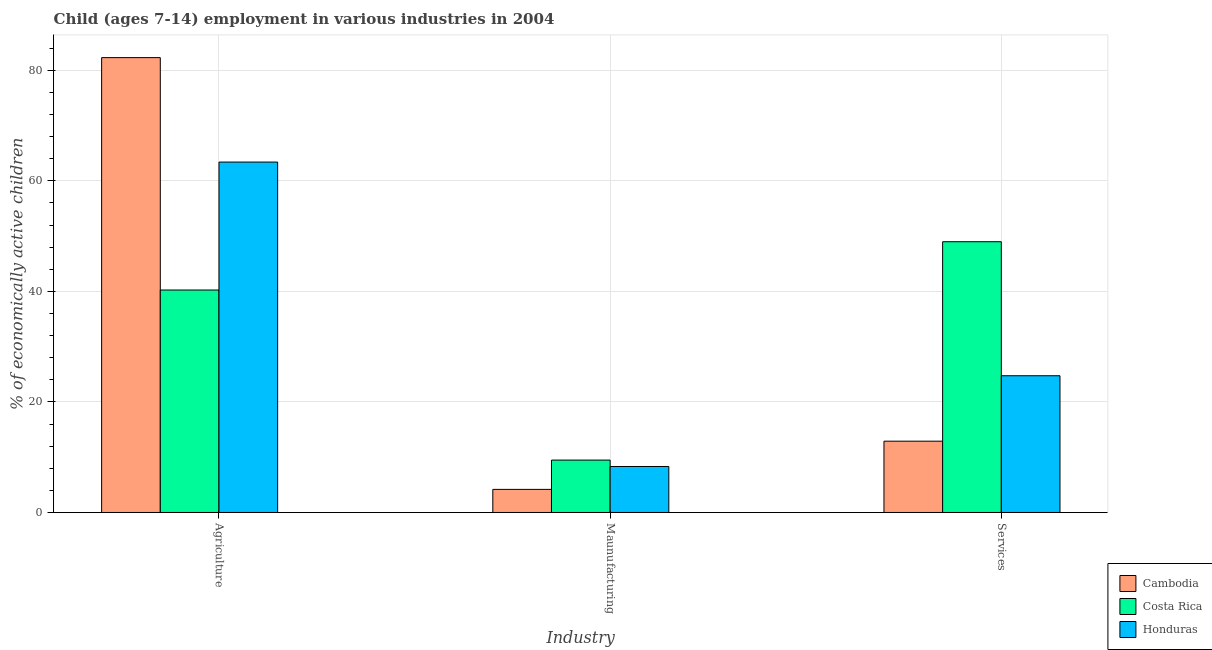How many different coloured bars are there?
Your answer should be very brief. 3. How many groups of bars are there?
Offer a terse response. 3. How many bars are there on the 2nd tick from the left?
Offer a very short reply. 3. How many bars are there on the 1st tick from the right?
Offer a terse response. 3. What is the label of the 1st group of bars from the left?
Offer a very short reply. Agriculture. What is the percentage of economically active children in manufacturing in Cambodia?
Offer a terse response. 4.18. Across all countries, what is the maximum percentage of economically active children in manufacturing?
Offer a very short reply. 9.48. In which country was the percentage of economically active children in manufacturing maximum?
Keep it short and to the point. Costa Rica. In which country was the percentage of economically active children in services minimum?
Offer a terse response. Cambodia. What is the total percentage of economically active children in services in the graph?
Offer a terse response. 86.63. What is the difference between the percentage of economically active children in manufacturing in Honduras and that in Cambodia?
Your answer should be very brief. 4.14. What is the difference between the percentage of economically active children in manufacturing in Honduras and the percentage of economically active children in services in Cambodia?
Give a very brief answer. -4.58. What is the average percentage of economically active children in agriculture per country?
Your answer should be very brief. 61.98. What is the difference between the percentage of economically active children in manufacturing and percentage of economically active children in services in Honduras?
Your answer should be compact. -16.42. What is the ratio of the percentage of economically active children in manufacturing in Costa Rica to that in Cambodia?
Your answer should be very brief. 2.27. Is the percentage of economically active children in manufacturing in Honduras less than that in Cambodia?
Keep it short and to the point. No. Is the difference between the percentage of economically active children in agriculture in Cambodia and Honduras greater than the difference between the percentage of economically active children in services in Cambodia and Honduras?
Ensure brevity in your answer.  Yes. What is the difference between the highest and the second highest percentage of economically active children in agriculture?
Your answer should be compact. 18.9. What is the difference between the highest and the lowest percentage of economically active children in agriculture?
Provide a short and direct response. 42.05. In how many countries, is the percentage of economically active children in agriculture greater than the average percentage of economically active children in agriculture taken over all countries?
Provide a short and direct response. 2. Is the sum of the percentage of economically active children in services in Honduras and Costa Rica greater than the maximum percentage of economically active children in agriculture across all countries?
Your answer should be compact. No. What does the 1st bar from the left in Maunufacturing represents?
Make the answer very short. Cambodia. What does the 1st bar from the right in Services represents?
Provide a succinct answer. Honduras. Is it the case that in every country, the sum of the percentage of economically active children in agriculture and percentage of economically active children in manufacturing is greater than the percentage of economically active children in services?
Your response must be concise. Yes. How many bars are there?
Offer a very short reply. 9. How many countries are there in the graph?
Make the answer very short. 3. Are the values on the major ticks of Y-axis written in scientific E-notation?
Your response must be concise. No. Does the graph contain any zero values?
Your response must be concise. No. Does the graph contain grids?
Make the answer very short. Yes. How many legend labels are there?
Your response must be concise. 3. What is the title of the graph?
Your answer should be very brief. Child (ages 7-14) employment in various industries in 2004. Does "Low & middle income" appear as one of the legend labels in the graph?
Offer a terse response. No. What is the label or title of the X-axis?
Make the answer very short. Industry. What is the label or title of the Y-axis?
Keep it short and to the point. % of economically active children. What is the % of economically active children in Cambodia in Agriculture?
Give a very brief answer. 82.3. What is the % of economically active children in Costa Rica in Agriculture?
Ensure brevity in your answer.  40.25. What is the % of economically active children in Honduras in Agriculture?
Offer a terse response. 63.4. What is the % of economically active children of Cambodia in Maunufacturing?
Offer a very short reply. 4.18. What is the % of economically active children in Costa Rica in Maunufacturing?
Your answer should be compact. 9.48. What is the % of economically active children of Honduras in Maunufacturing?
Provide a succinct answer. 8.32. What is the % of economically active children in Costa Rica in Services?
Provide a short and direct response. 48.99. What is the % of economically active children in Honduras in Services?
Provide a succinct answer. 24.74. Across all Industry, what is the maximum % of economically active children in Cambodia?
Provide a succinct answer. 82.3. Across all Industry, what is the maximum % of economically active children of Costa Rica?
Make the answer very short. 48.99. Across all Industry, what is the maximum % of economically active children of Honduras?
Keep it short and to the point. 63.4. Across all Industry, what is the minimum % of economically active children of Cambodia?
Give a very brief answer. 4.18. Across all Industry, what is the minimum % of economically active children of Costa Rica?
Ensure brevity in your answer.  9.48. Across all Industry, what is the minimum % of economically active children of Honduras?
Offer a terse response. 8.32. What is the total % of economically active children of Cambodia in the graph?
Offer a terse response. 99.38. What is the total % of economically active children in Costa Rica in the graph?
Your answer should be very brief. 98.72. What is the total % of economically active children in Honduras in the graph?
Provide a short and direct response. 96.46. What is the difference between the % of economically active children in Cambodia in Agriculture and that in Maunufacturing?
Make the answer very short. 78.12. What is the difference between the % of economically active children in Costa Rica in Agriculture and that in Maunufacturing?
Your answer should be compact. 30.77. What is the difference between the % of economically active children of Honduras in Agriculture and that in Maunufacturing?
Make the answer very short. 55.08. What is the difference between the % of economically active children of Cambodia in Agriculture and that in Services?
Provide a short and direct response. 69.4. What is the difference between the % of economically active children of Costa Rica in Agriculture and that in Services?
Your response must be concise. -8.74. What is the difference between the % of economically active children of Honduras in Agriculture and that in Services?
Keep it short and to the point. 38.66. What is the difference between the % of economically active children in Cambodia in Maunufacturing and that in Services?
Provide a succinct answer. -8.72. What is the difference between the % of economically active children of Costa Rica in Maunufacturing and that in Services?
Provide a short and direct response. -39.51. What is the difference between the % of economically active children in Honduras in Maunufacturing and that in Services?
Give a very brief answer. -16.42. What is the difference between the % of economically active children of Cambodia in Agriculture and the % of economically active children of Costa Rica in Maunufacturing?
Your answer should be very brief. 72.82. What is the difference between the % of economically active children of Cambodia in Agriculture and the % of economically active children of Honduras in Maunufacturing?
Offer a very short reply. 73.98. What is the difference between the % of economically active children of Costa Rica in Agriculture and the % of economically active children of Honduras in Maunufacturing?
Ensure brevity in your answer.  31.93. What is the difference between the % of economically active children in Cambodia in Agriculture and the % of economically active children in Costa Rica in Services?
Provide a succinct answer. 33.31. What is the difference between the % of economically active children of Cambodia in Agriculture and the % of economically active children of Honduras in Services?
Give a very brief answer. 57.56. What is the difference between the % of economically active children in Costa Rica in Agriculture and the % of economically active children in Honduras in Services?
Provide a short and direct response. 15.51. What is the difference between the % of economically active children of Cambodia in Maunufacturing and the % of economically active children of Costa Rica in Services?
Keep it short and to the point. -44.81. What is the difference between the % of economically active children of Cambodia in Maunufacturing and the % of economically active children of Honduras in Services?
Provide a short and direct response. -20.56. What is the difference between the % of economically active children in Costa Rica in Maunufacturing and the % of economically active children in Honduras in Services?
Make the answer very short. -15.26. What is the average % of economically active children of Cambodia per Industry?
Keep it short and to the point. 33.13. What is the average % of economically active children of Costa Rica per Industry?
Make the answer very short. 32.91. What is the average % of economically active children of Honduras per Industry?
Make the answer very short. 32.15. What is the difference between the % of economically active children in Cambodia and % of economically active children in Costa Rica in Agriculture?
Your response must be concise. 42.05. What is the difference between the % of economically active children in Cambodia and % of economically active children in Honduras in Agriculture?
Provide a succinct answer. 18.9. What is the difference between the % of economically active children of Costa Rica and % of economically active children of Honduras in Agriculture?
Your response must be concise. -23.15. What is the difference between the % of economically active children of Cambodia and % of economically active children of Honduras in Maunufacturing?
Ensure brevity in your answer.  -4.14. What is the difference between the % of economically active children of Costa Rica and % of economically active children of Honduras in Maunufacturing?
Give a very brief answer. 1.16. What is the difference between the % of economically active children in Cambodia and % of economically active children in Costa Rica in Services?
Your response must be concise. -36.09. What is the difference between the % of economically active children in Cambodia and % of economically active children in Honduras in Services?
Keep it short and to the point. -11.84. What is the difference between the % of economically active children of Costa Rica and % of economically active children of Honduras in Services?
Ensure brevity in your answer.  24.25. What is the ratio of the % of economically active children in Cambodia in Agriculture to that in Maunufacturing?
Offer a very short reply. 19.69. What is the ratio of the % of economically active children of Costa Rica in Agriculture to that in Maunufacturing?
Provide a succinct answer. 4.25. What is the ratio of the % of economically active children of Honduras in Agriculture to that in Maunufacturing?
Provide a short and direct response. 7.62. What is the ratio of the % of economically active children in Cambodia in Agriculture to that in Services?
Keep it short and to the point. 6.38. What is the ratio of the % of economically active children in Costa Rica in Agriculture to that in Services?
Offer a very short reply. 0.82. What is the ratio of the % of economically active children of Honduras in Agriculture to that in Services?
Make the answer very short. 2.56. What is the ratio of the % of economically active children of Cambodia in Maunufacturing to that in Services?
Offer a terse response. 0.32. What is the ratio of the % of economically active children of Costa Rica in Maunufacturing to that in Services?
Make the answer very short. 0.19. What is the ratio of the % of economically active children in Honduras in Maunufacturing to that in Services?
Offer a terse response. 0.34. What is the difference between the highest and the second highest % of economically active children in Cambodia?
Provide a short and direct response. 69.4. What is the difference between the highest and the second highest % of economically active children in Costa Rica?
Provide a succinct answer. 8.74. What is the difference between the highest and the second highest % of economically active children in Honduras?
Provide a short and direct response. 38.66. What is the difference between the highest and the lowest % of economically active children of Cambodia?
Your answer should be compact. 78.12. What is the difference between the highest and the lowest % of economically active children of Costa Rica?
Make the answer very short. 39.51. What is the difference between the highest and the lowest % of economically active children in Honduras?
Your answer should be very brief. 55.08. 